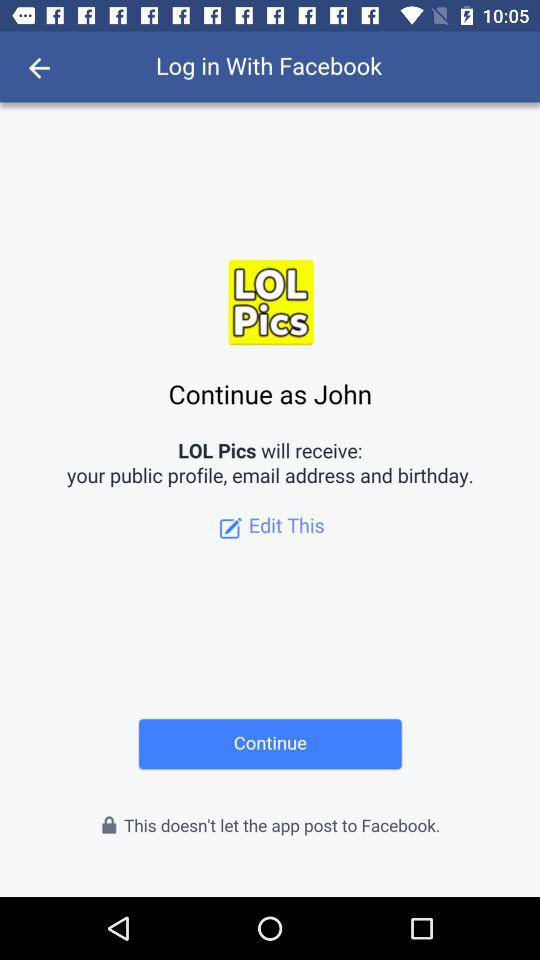What is the surname?
When the provided information is insufficient, respond with <no answer>. <no answer> 